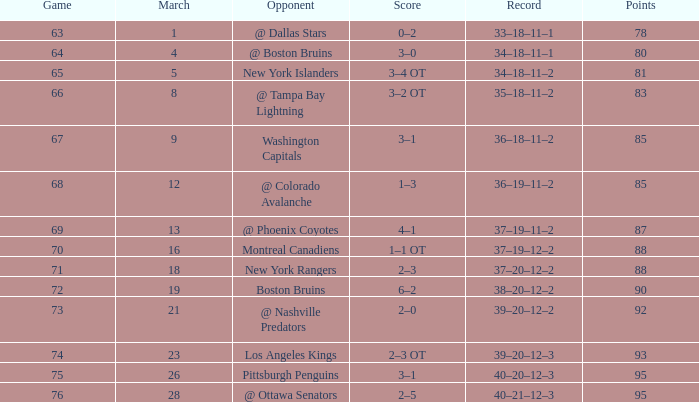Which adversary possesses a 38-20-12-2 record? Boston Bruins. 